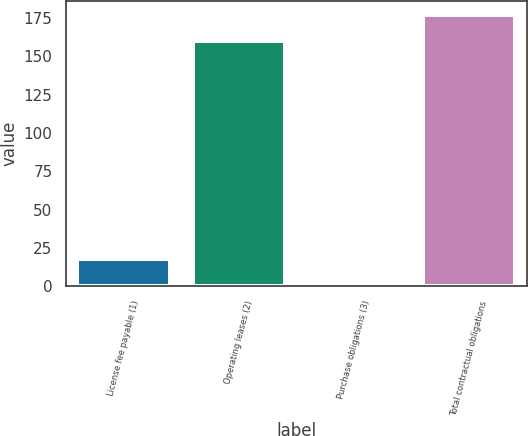Convert chart. <chart><loc_0><loc_0><loc_500><loc_500><bar_chart><fcel>License fee payable (1)<fcel>Operating leases (2)<fcel>Purchase obligations (3)<fcel>Total contractual obligations<nl><fcel>18<fcel>160<fcel>1<fcel>177<nl></chart> 